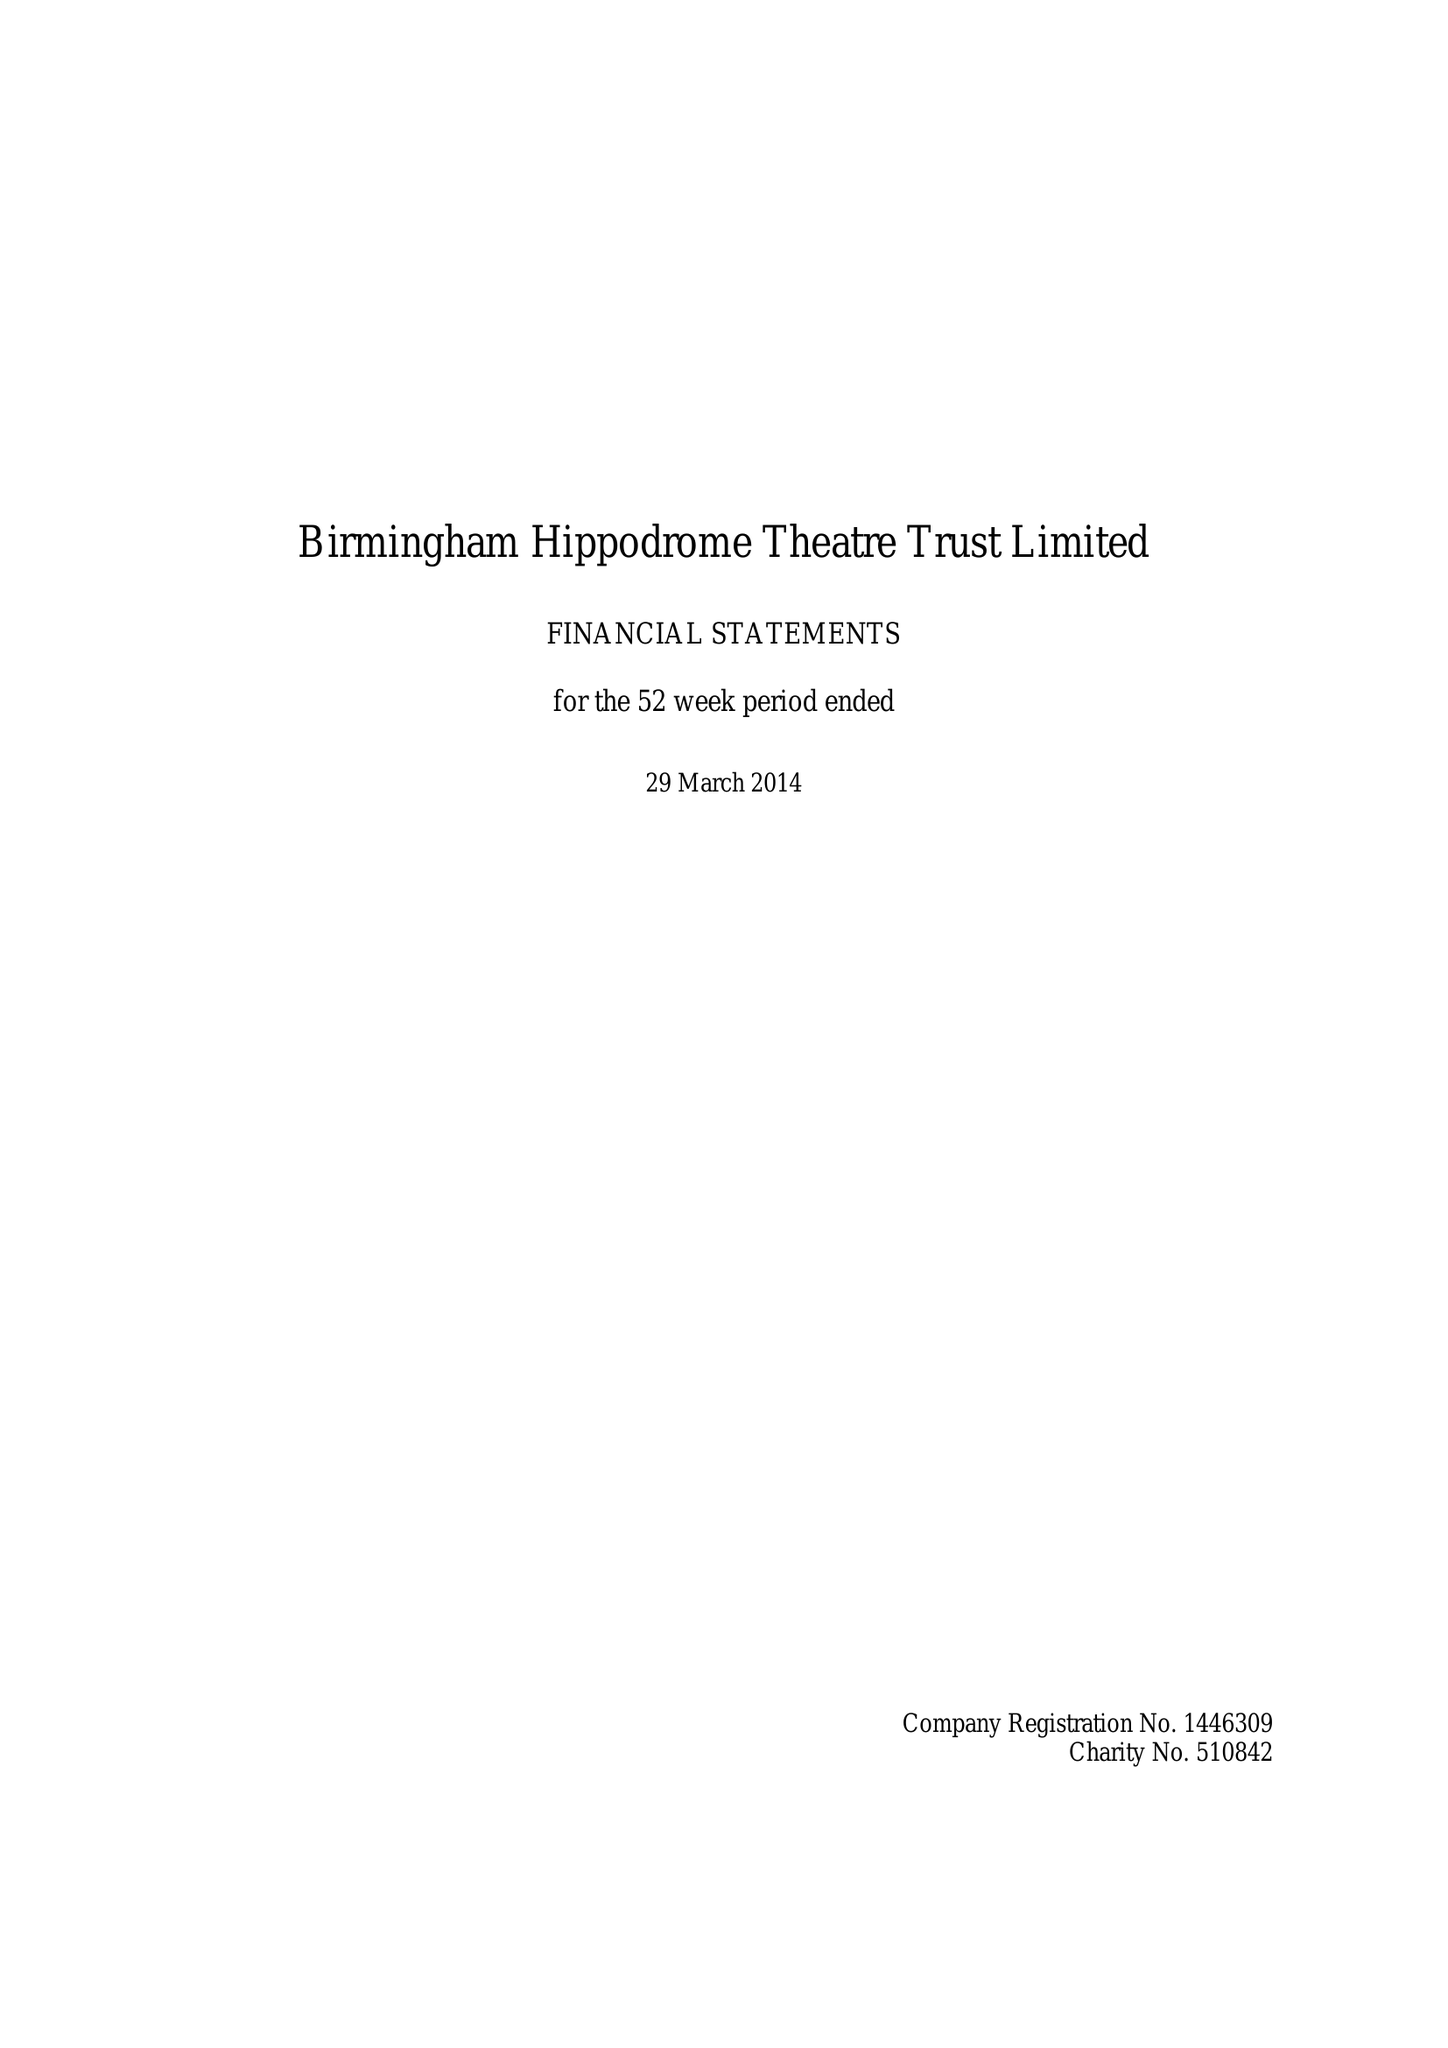What is the value for the address__postcode?
Answer the question using a single word or phrase. B5 4TB 